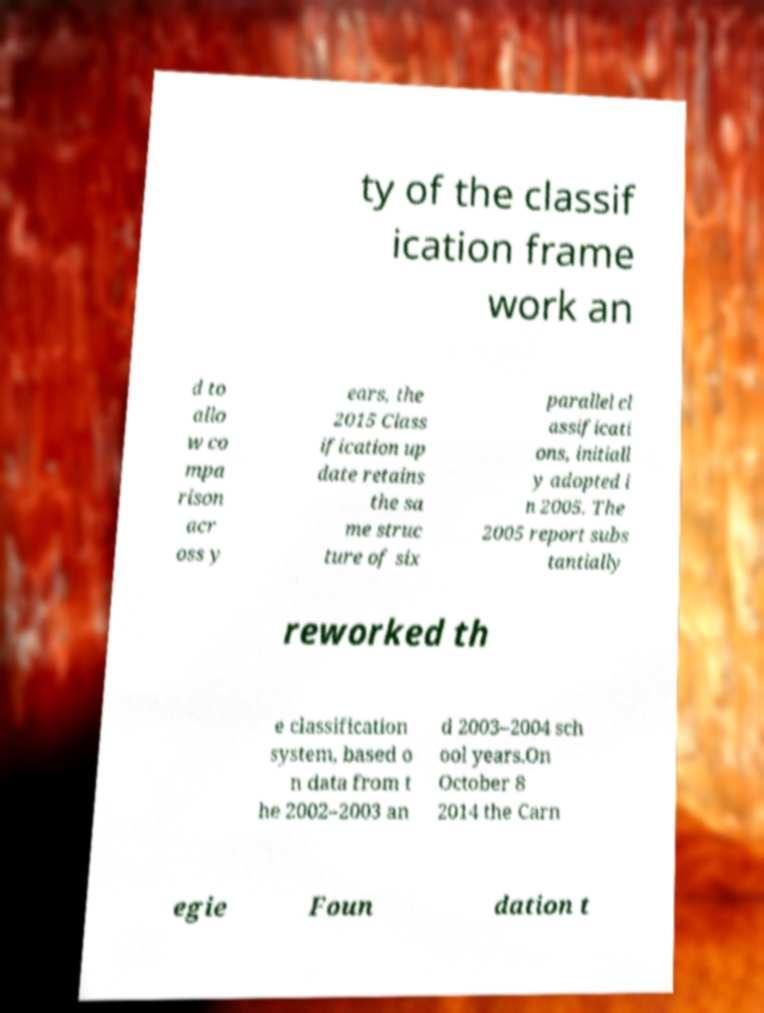For documentation purposes, I need the text within this image transcribed. Could you provide that? ty of the classif ication frame work an d to allo w co mpa rison acr oss y ears, the 2015 Class ification up date retains the sa me struc ture of six parallel cl assificati ons, initiall y adopted i n 2005. The 2005 report subs tantially reworked th e classification system, based o n data from t he 2002–2003 an d 2003–2004 sch ool years.On October 8 2014 the Carn egie Foun dation t 